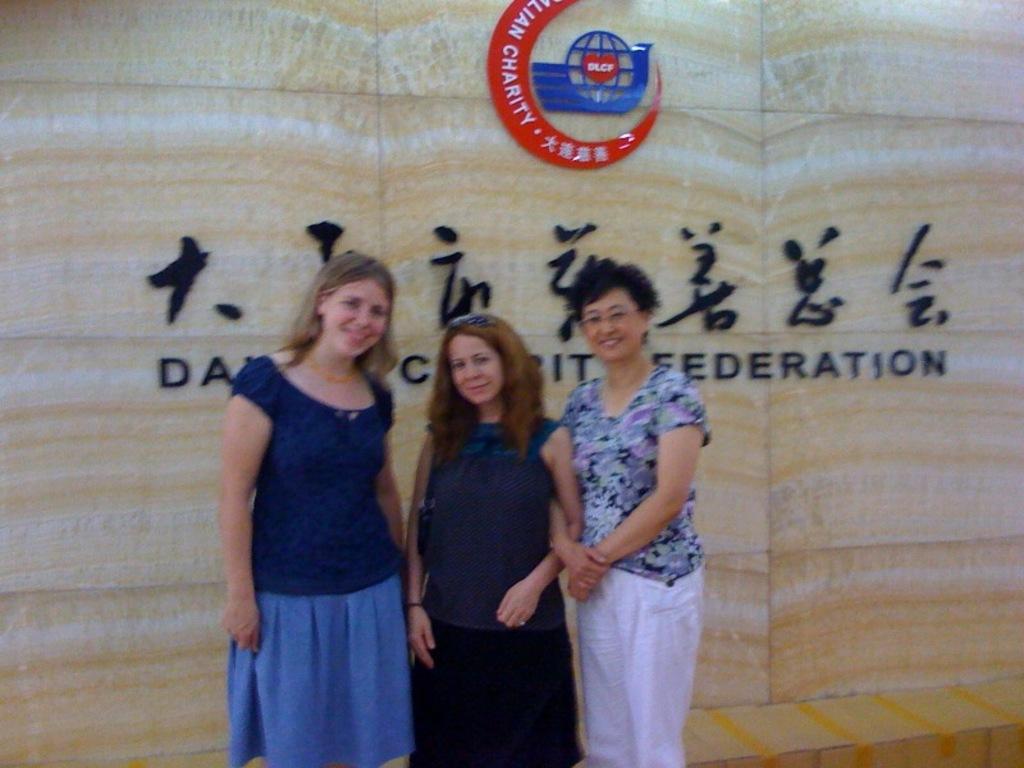Describe this image in one or two sentences. In this image I can see three persons standing. Behind the person there is a wall on which some text written on it and some logo represented over the wall. 